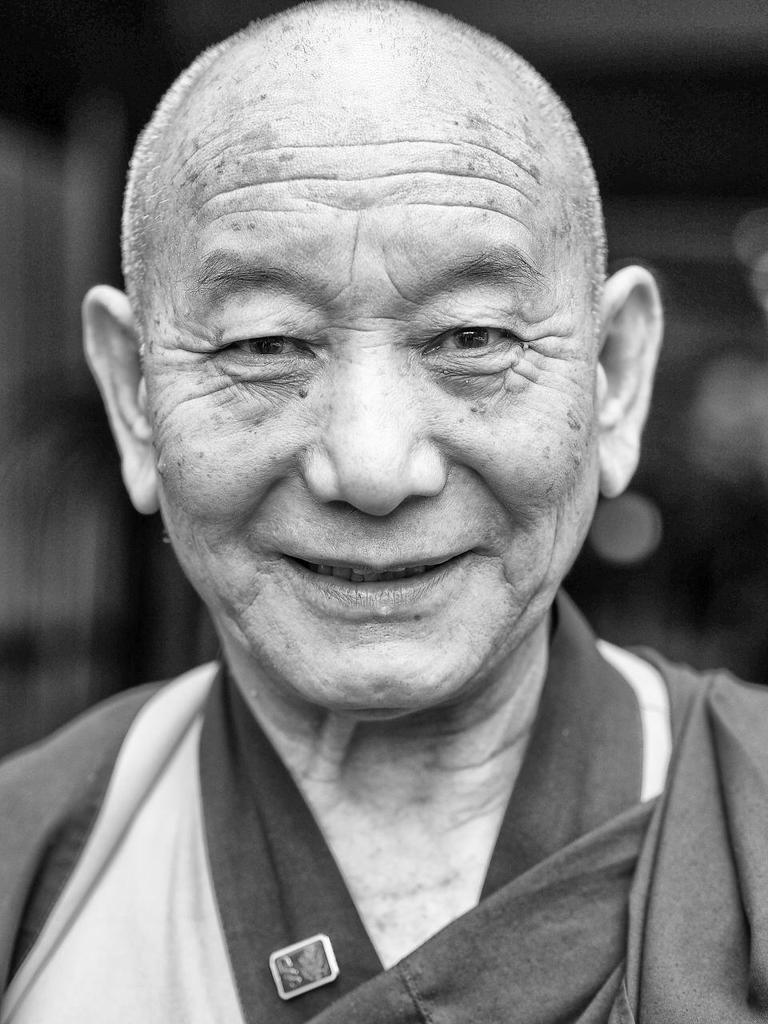What is the main subject in the foreground of the image? There is a man in the foreground of the image. What is the man doing in the image? The man is smiling in the image. Can you describe the background of the image? The background of the image is blurred. Can you tell me how many jellyfish are swimming in the background of the image? There are no jellyfish present in the image; the background is blurred. 